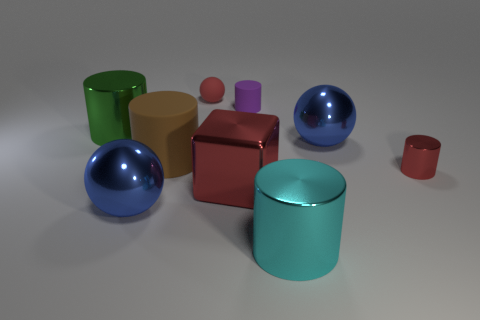The large cyan thing has what shape?
Your answer should be very brief. Cylinder. How many other rubber spheres have the same color as the matte ball?
Ensure brevity in your answer.  0. What material is the large blue thing on the left side of the blue shiny thing that is behind the sphere that is in front of the tiny metal cylinder made of?
Make the answer very short. Metal. How many cyan objects are big cylinders or balls?
Make the answer very short. 1. What size is the red shiny thing on the left side of the metallic ball that is behind the red cylinder that is behind the big red cube?
Provide a succinct answer. Large. There is another cyan thing that is the same shape as the large rubber object; what is its size?
Make the answer very short. Large. How many tiny things are metallic balls or metallic cubes?
Give a very brief answer. 0. Are the sphere right of the matte sphere and the purple thing in front of the tiny red matte object made of the same material?
Provide a short and direct response. No. There is a large red thing that is in front of the red rubber sphere; what is its material?
Give a very brief answer. Metal. How many metal objects are either tiny purple cylinders or blue objects?
Offer a terse response. 2. 